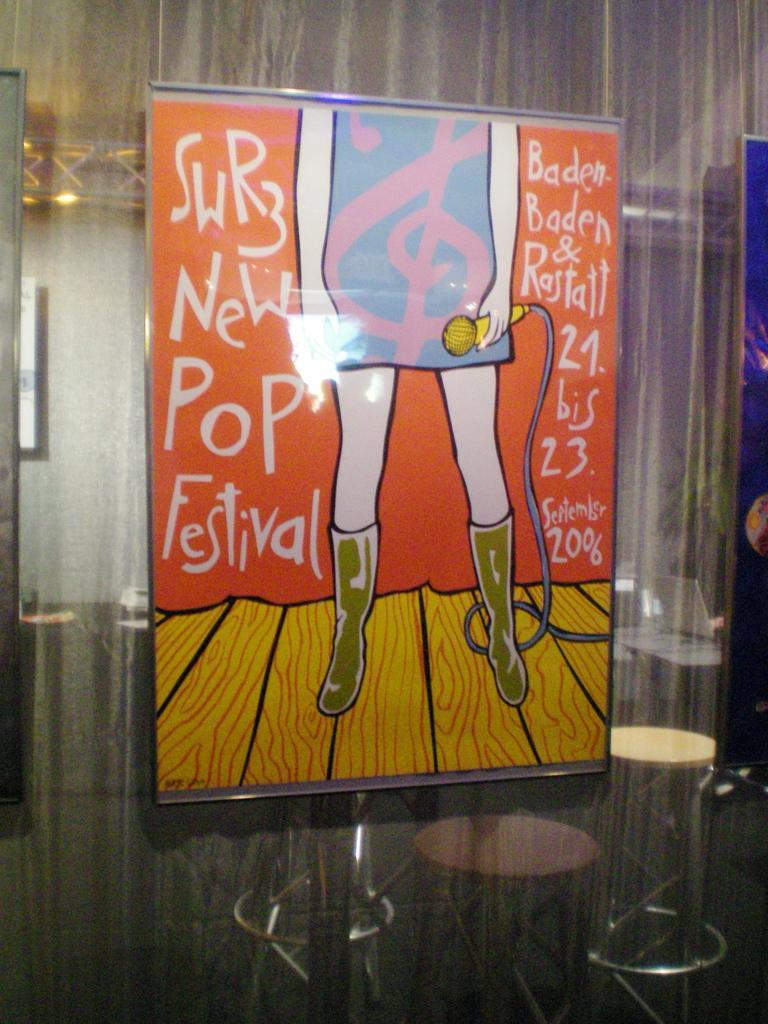Can you describe this image briefly? There is a photo frame of an animated image. A person is standing holding a mic. 